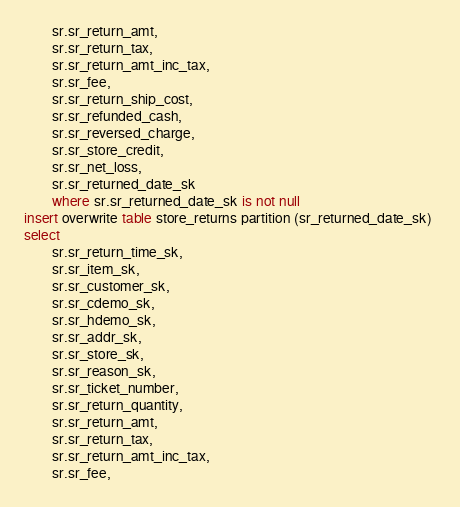Convert code to text. <code><loc_0><loc_0><loc_500><loc_500><_SQL_>        sr.sr_return_amt,
        sr.sr_return_tax,
        sr.sr_return_amt_inc_tax,
        sr.sr_fee,
        sr.sr_return_ship_cost,
        sr.sr_refunded_cash,
        sr.sr_reversed_charge,
        sr.sr_store_credit,
        sr.sr_net_loss,
        sr.sr_returned_date_sk
        where sr.sr_returned_date_sk is not null
insert overwrite table store_returns partition (sr_returned_date_sk) 
select
        sr.sr_return_time_sk,
        sr.sr_item_sk,
        sr.sr_customer_sk,
        sr.sr_cdemo_sk,
        sr.sr_hdemo_sk,
        sr.sr_addr_sk,
        sr.sr_store_sk,
        sr.sr_reason_sk,
        sr.sr_ticket_number,
        sr.sr_return_quantity,
        sr.sr_return_amt,
        sr.sr_return_tax,
        sr.sr_return_amt_inc_tax,
        sr.sr_fee,</code> 